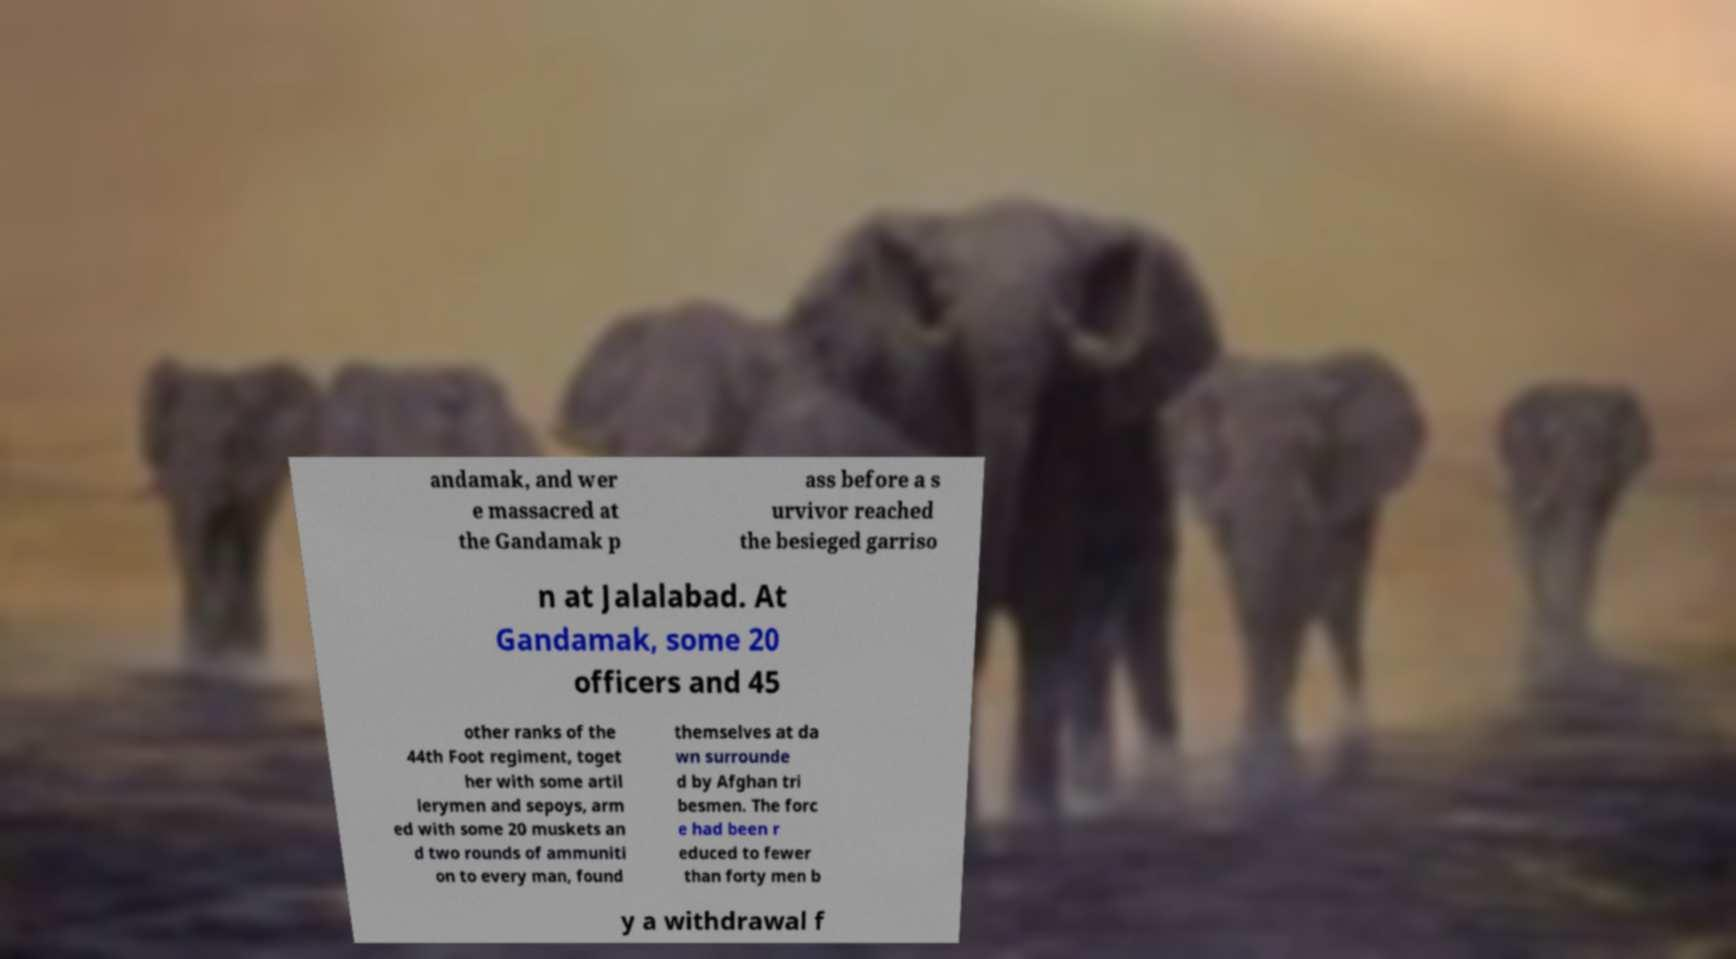Could you assist in decoding the text presented in this image and type it out clearly? andamak, and wer e massacred at the Gandamak p ass before a s urvivor reached the besieged garriso n at Jalalabad. At Gandamak, some 20 officers and 45 other ranks of the 44th Foot regiment, toget her with some artil lerymen and sepoys, arm ed with some 20 muskets an d two rounds of ammuniti on to every man, found themselves at da wn surrounde d by Afghan tri besmen. The forc e had been r educed to fewer than forty men b y a withdrawal f 